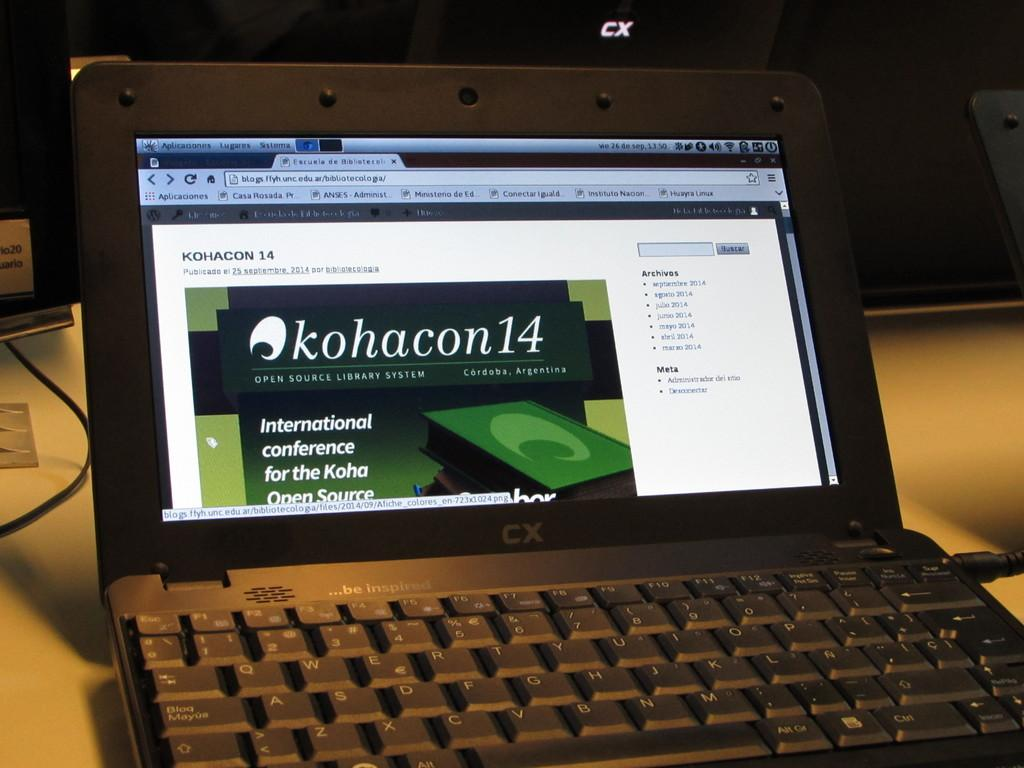Provide a one-sentence caption for the provided image. A small black laptop with a web page referring to an international conference. 